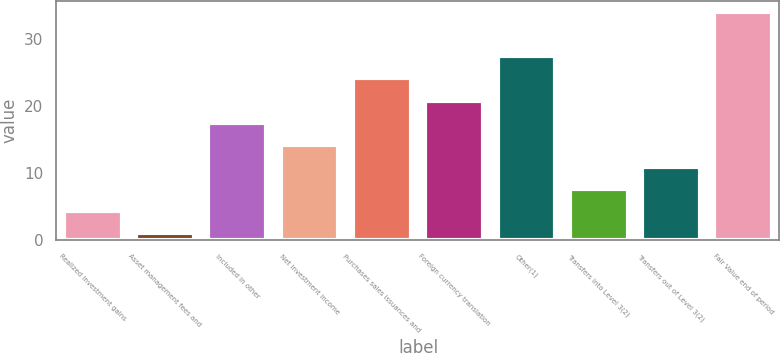Convert chart. <chart><loc_0><loc_0><loc_500><loc_500><bar_chart><fcel>Realized investment gains<fcel>Asset management fees and<fcel>Included in other<fcel>Net investment income<fcel>Purchases sales issuances and<fcel>Foreign currency translation<fcel>Other(1)<fcel>Transfers into Level 3(2)<fcel>Transfers out of Level 3(2)<fcel>Fair Value end of period<nl><fcel>4.3<fcel>1<fcel>17.5<fcel>14.2<fcel>24.1<fcel>20.8<fcel>27.4<fcel>7.6<fcel>10.9<fcel>34<nl></chart> 